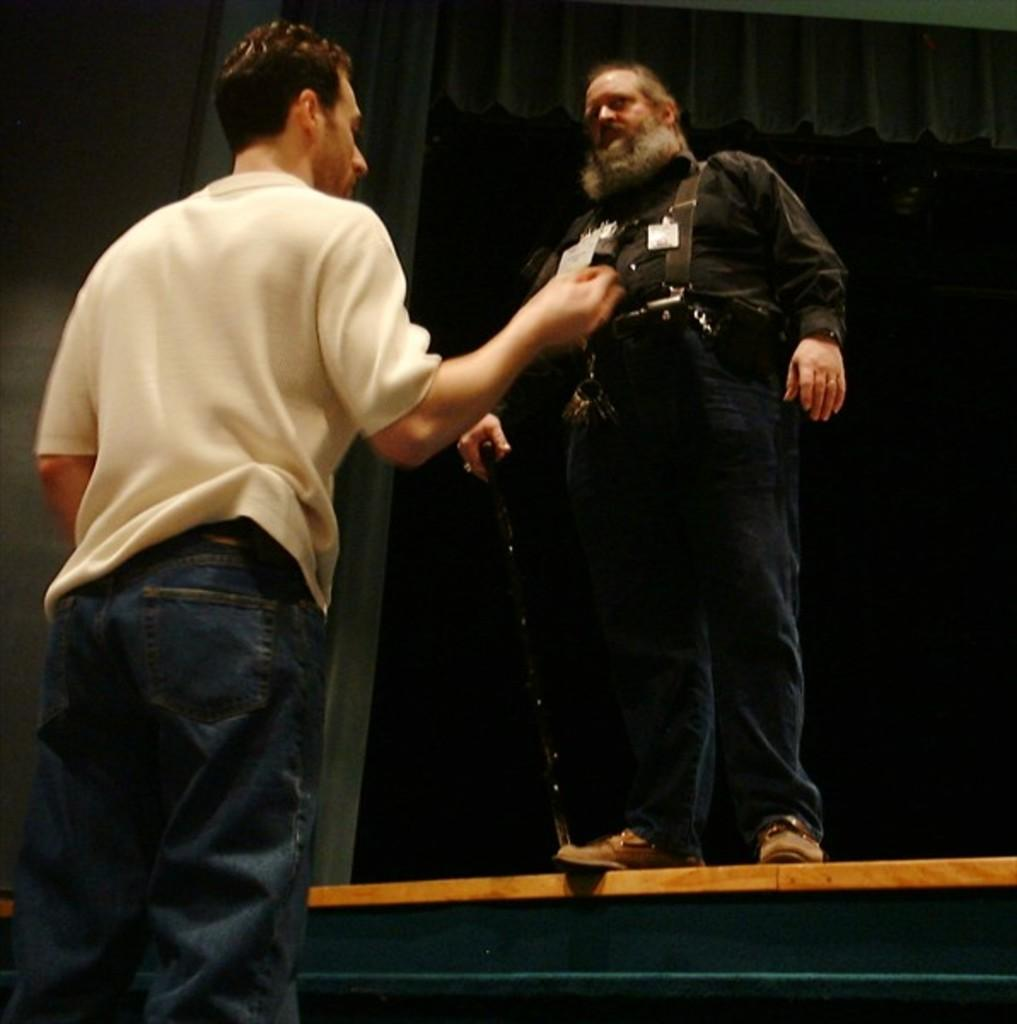How many people are in the image? There are two men in the image. What is the man on the right side holding? The man on the right side is holding a stick. What can be observed about the background of the image? The background of the image is dark. What type of animal can be seen in the image? There is no animal present in the image; it features two men, one of whom is holding a stick. What is the plot of the story unfolding in the image? There is no story or plot depicted in the image; it simply shows two men, one holding a stick, against a dark background. 